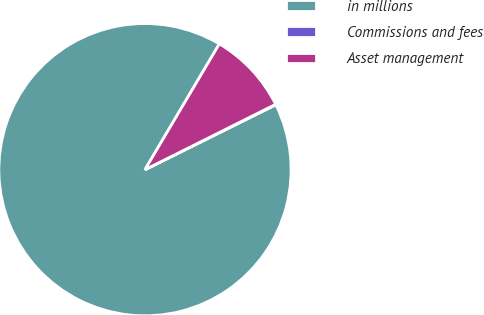Convert chart to OTSL. <chart><loc_0><loc_0><loc_500><loc_500><pie_chart><fcel>in millions<fcel>Commissions and fees<fcel>Asset management<nl><fcel>90.83%<fcel>0.05%<fcel>9.12%<nl></chart> 